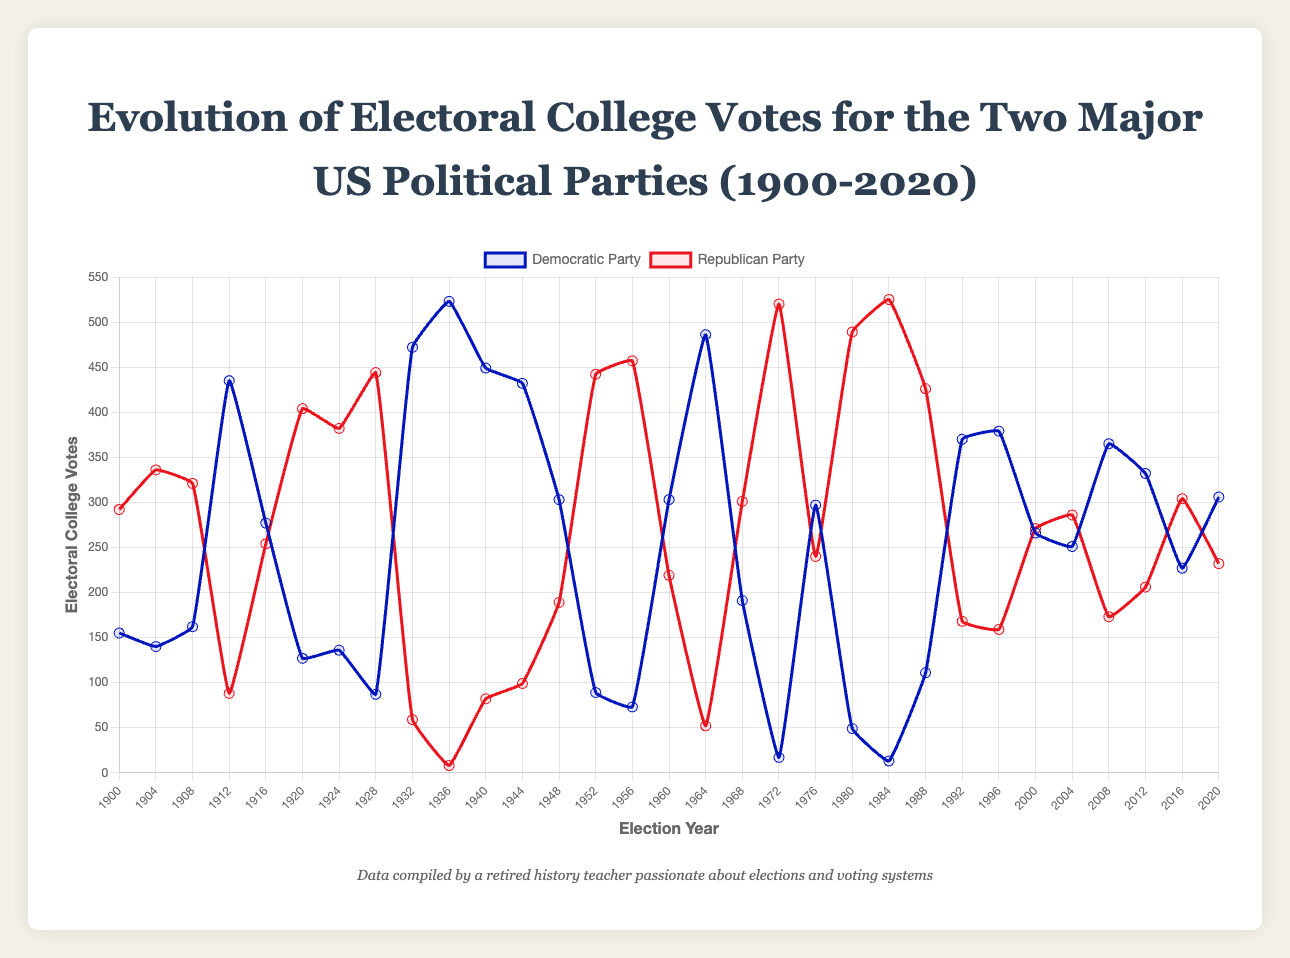Which party received more electoral votes in 1936? In 1936, the Democratic Party received 523 electoral votes, while the Republican Party received only 8 votes.
Answer: Democratic Party What was the trend for the Democratic Party's electoral votes between 1928 and 1936? The Democratic Party's electoral votes increased significantly from 87 in 1928 to 472 in 1932, and then to 523 in 1936.
Answer: Increasing In which year did the Republican Party receive its highest electoral vote count? Observing the plot, the Republican Party received its highest electoral vote count in 1984, with 525 votes.
Answer: 1984 Which election saw the closest contest between the two parties in terms of electoral votes? The closest contest occurred in 1916, where the Democratic Party received 277 votes and the Republican Party received 254 votes, a difference of just 23 votes.
Answer: 1916 How many times did the Democratic Party receive over 450 electoral votes? By examining the data points for the Democratic Party, they received over 450 electoral votes in the years 1932, 1936, 1964, and 1976.
Answer: 4 times Identify periods when the Republican Party had more electoral votes successively for at least three elections. The Republican Party had more electoral votes successively for three or more elections during the periods 1920-1928 and 1980-1988.
Answer: 1920-1928, 1980-1988 Compare the electoral votes of the Democratic Party in 1948 and 1996. Which year did they receive more, and by how much? In 1948, the Democratic Party received 303 electoral votes, and in 1996, they received 379 electoral votes. The difference is 379 - 303 = 76 votes.
Answer: 1996, by 76 votes Which party had the largest drop in electoral votes in consecutive elections? The Democratic Party had the largest drop between 1964 and 1968, dropping from 486 to 191, a difference of 295 votes.
Answer: Democratic Party, 295 votes What are the median electoral votes for the Republican Party across all elections shown? To find the median, list all the Republican Party electoral votes in order. The middle value is the median. Ordered list: 8, 13, 49, 52, 59, 82, 88, 99, 159, 168, 173, 189, 206, 219, 232, 240, 254, 271, 286, 292, 301, 321, 336, 382, 404, 426, 442, 444, 457, 489, 520, 525. The middle values are 240 and 254. Median = (240 + 254)/2 = 247.
Answer: 247 Which party showed a clear winning trend in the elections between 1920 and 1932? Looking at the plot, the Republican Party had significantly higher electoral votes in the elections of 1920, 1924, and 1928, indicating a clear winning trend during this period.
Answer: Republican Party 